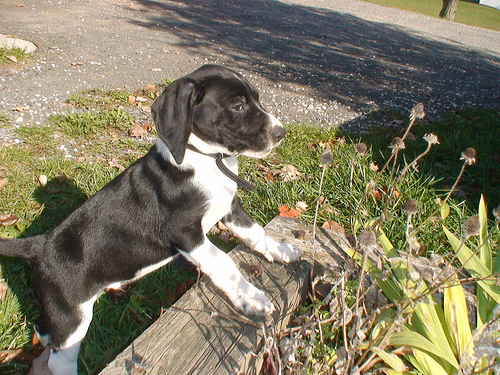<image>
Can you confirm if the dog is behind the bench? Yes. From this viewpoint, the dog is positioned behind the bench, with the bench partially or fully occluding the dog. 